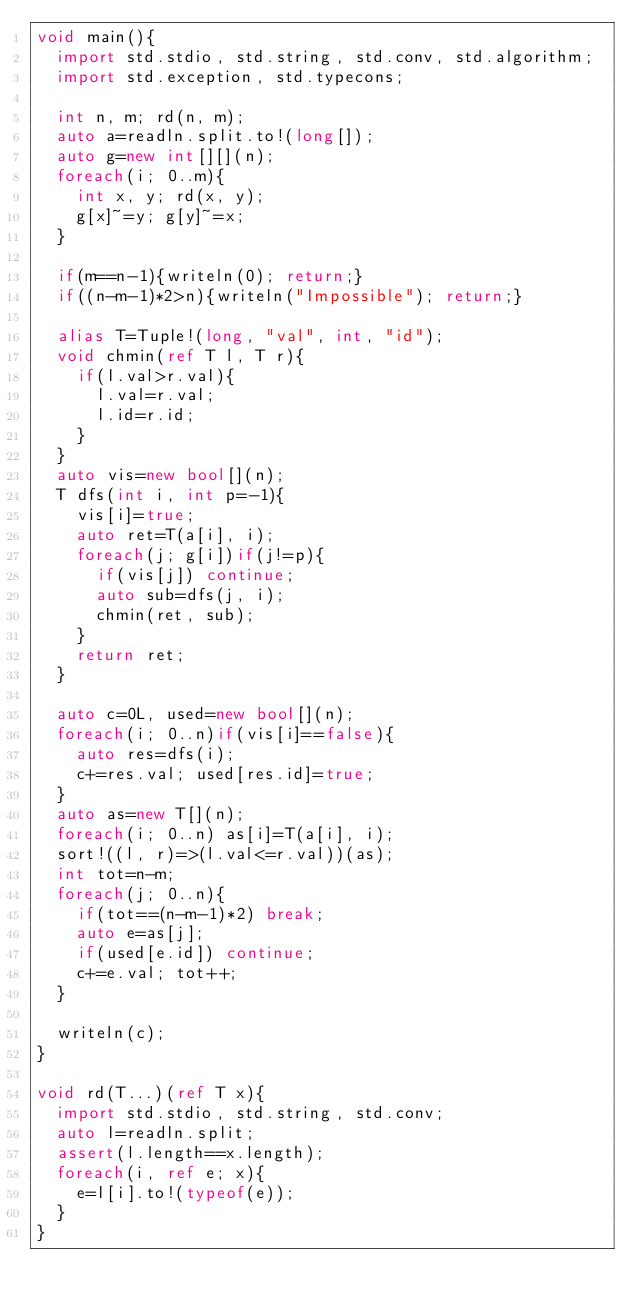<code> <loc_0><loc_0><loc_500><loc_500><_D_>void main(){
  import std.stdio, std.string, std.conv, std.algorithm;
  import std.exception, std.typecons;
  
  int n, m; rd(n, m);
  auto a=readln.split.to!(long[]);
  auto g=new int[][](n);
  foreach(i; 0..m){
    int x, y; rd(x, y);
    g[x]~=y; g[y]~=x;
  }

  if(m==n-1){writeln(0); return;}
  if((n-m-1)*2>n){writeln("Impossible"); return;}

  alias T=Tuple!(long, "val", int, "id");
  void chmin(ref T l, T r){
    if(l.val>r.val){
      l.val=r.val;
      l.id=r.id;
    }
  }
  auto vis=new bool[](n);
  T dfs(int i, int p=-1){
    vis[i]=true;
    auto ret=T(a[i], i);
    foreach(j; g[i])if(j!=p){
      if(vis[j]) continue;
      auto sub=dfs(j, i);
      chmin(ret, sub);
    }
    return ret;
  }

  auto c=0L, used=new bool[](n);
  foreach(i; 0..n)if(vis[i]==false){
    auto res=dfs(i);
    c+=res.val; used[res.id]=true;
  }
  auto as=new T[](n);
  foreach(i; 0..n) as[i]=T(a[i], i);
  sort!((l, r)=>(l.val<=r.val))(as);
  int tot=n-m;
  foreach(j; 0..n){
    if(tot==(n-m-1)*2) break;
    auto e=as[j];
    if(used[e.id]) continue;
    c+=e.val; tot++;
  }

  writeln(c);
}

void rd(T...)(ref T x){
  import std.stdio, std.string, std.conv;
  auto l=readln.split;
  assert(l.length==x.length);
  foreach(i, ref e; x){
    e=l[i].to!(typeof(e));
  }
}
</code> 